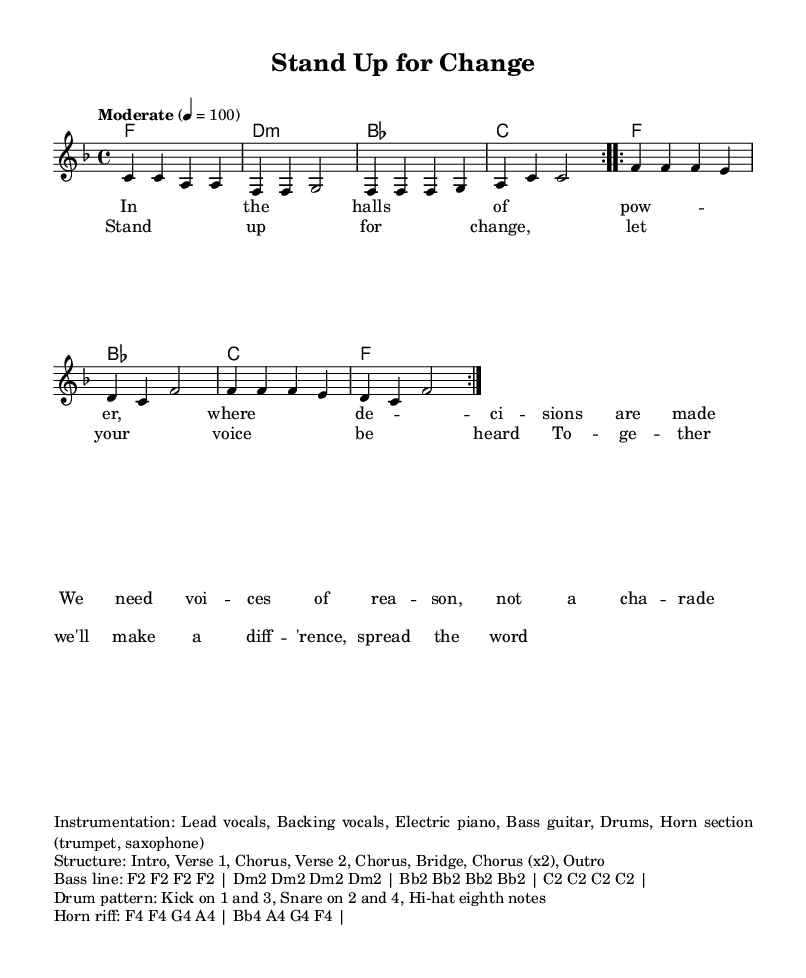What is the key signature of this music? The key signature is indicated at the beginning of the score. It shows the presence of one flat, which means it is in the key of F major.
Answer: F major What is the time signature of this piece? The time signature is located right after the key signature. It shows a 4/4 time signature, meaning there are four beats per measure.
Answer: 4/4 What is the tempo marking for this composition? The tempo marking is found near the top of the score, indicating the speed of the music. "Moderate" with a metronome marking of 100 beats per minute is noted.
Answer: Moderate 100 How many times is the chorus repeated? The structure of the song is outlined in a markup section, showing that the chorus is repeated twice at the end of the piece.
Answer: 2 What instruments are included in the instrumentation? The instrumentation details are provided in the markup section, listing the instruments that participate in the performance. These include lead vocals, backing vocals, electric piano, bass guitar, drums, and a horn section (trumpet, saxophone).
Answer: Lead vocals, Backing vocals, Electric piano, Bass guitar, Drums, Horn section What is the first lyric line of the verse? The lyrics for the verse are shown in the lyric mode section of the score. The first line reads, "In the halls of pow -- er, where de -- ci -- sions are made."
Answer: In the halls of pow -- er, where de -- ci -- sions are made What chord is used as the first harmony? The harmonic progression begins with the first chord, which is indicated in the chord names section. The first harmony shown is F major.
Answer: F 